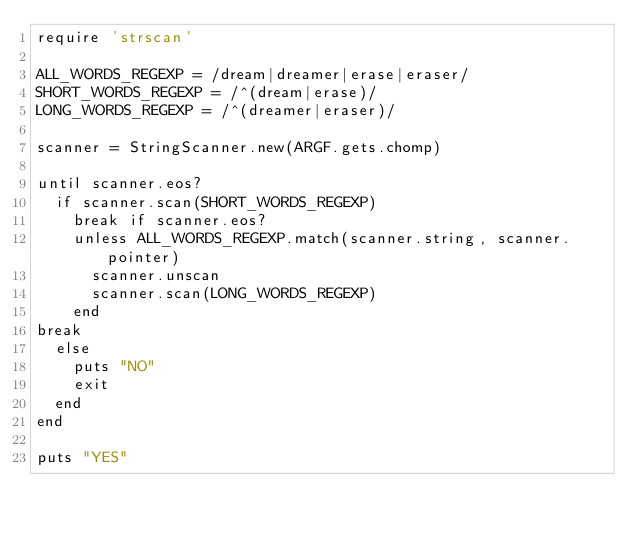<code> <loc_0><loc_0><loc_500><loc_500><_Ruby_>require 'strscan'

ALL_WORDS_REGEXP = /dream|dreamer|erase|eraser/
SHORT_WORDS_REGEXP = /^(dream|erase)/
LONG_WORDS_REGEXP = /^(dreamer|eraser)/

scanner = StringScanner.new(ARGF.gets.chomp)

until scanner.eos?
  if scanner.scan(SHORT_WORDS_REGEXP)
    break if scanner.eos?
    unless ALL_WORDS_REGEXP.match(scanner.string, scanner.pointer)
      scanner.unscan
      scanner.scan(LONG_WORDS_REGEXP)
    end
break
  else
    puts "NO"
    exit
  end
end

puts "YES"
</code> 